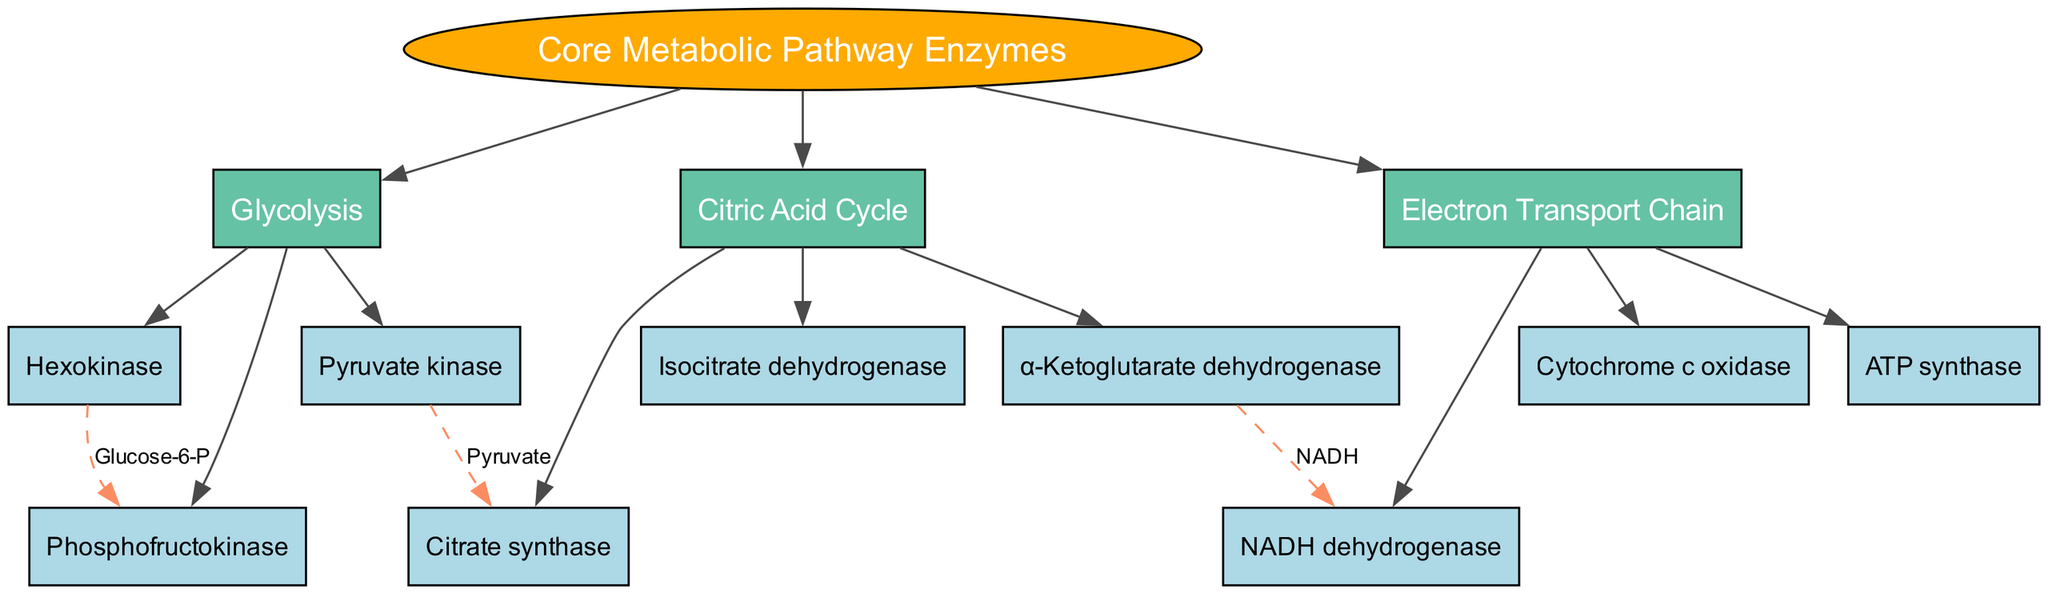What is the root of the tree? The root of the tree is labeled as "Core Metabolic Pathway Enzymes," which serves as the main starting point for the diagram.
Answer: Core Metabolic Pathway Enzymes How many branches are there? There are three branches stemming from the root: Glycolysis, Citric Acid Cycle, and Electron Transport Chain. Counting these branches gives a total of three.
Answer: 3 Which enzyme is a precursor to Citric Acid Cycle? The relationship from "Pyruvate kinase" to "Citrate synthase" indicates that Pyruvate kinase leads into the Citric Acid Cycle, establishing its role as a precursor.
Answer: Pyruvate kinase What color represents the enzymes in the branches? Enzymes within the branches are represented in light blue color according to the node style specified in the diagram.
Answer: Light blue Which enzyme connects to NADH dehydrogenase? The diagram shows that "α-Ketoglutarate dehydrogenase" is connected to "NADH dehydrogenase" via a dashed line, indicating a relationship between the two.
Answer: α-Ketoglutarate dehydrogenase Name an enzyme in the Glycolysis branch. One enzyme within the Glycolysis branch is "Hexokinase," as listed under that specific branch in the diagram.
Answer: Hexokinase What type of relationship is shown between Hexokinase and Phosphofructokinase? The relationship between Hexokinase and Phosphofructokinase is shown as a dashed line labeled "Glucose-6-P," indicating a specific biochemical interaction.
Answer: Glucose-6-P How many enzymes are listed under the Citric Acid Cycle? There are three enzymes listed under the Citric Acid Cycle: Citrate synthase, Isocitrate dehydrogenase, and α-Ketoglutarate dehydrogenase, resulting in a total count of three.
Answer: 3 What links Pyruvate kinase to the Citric Acid Cycle? Pyruvate kinase is linked to the Citric Acid Cycle by the relationship labeled "Pyruvate," showing the transition from glycolysis to the citric acid cycle.
Answer: Pyruvate 